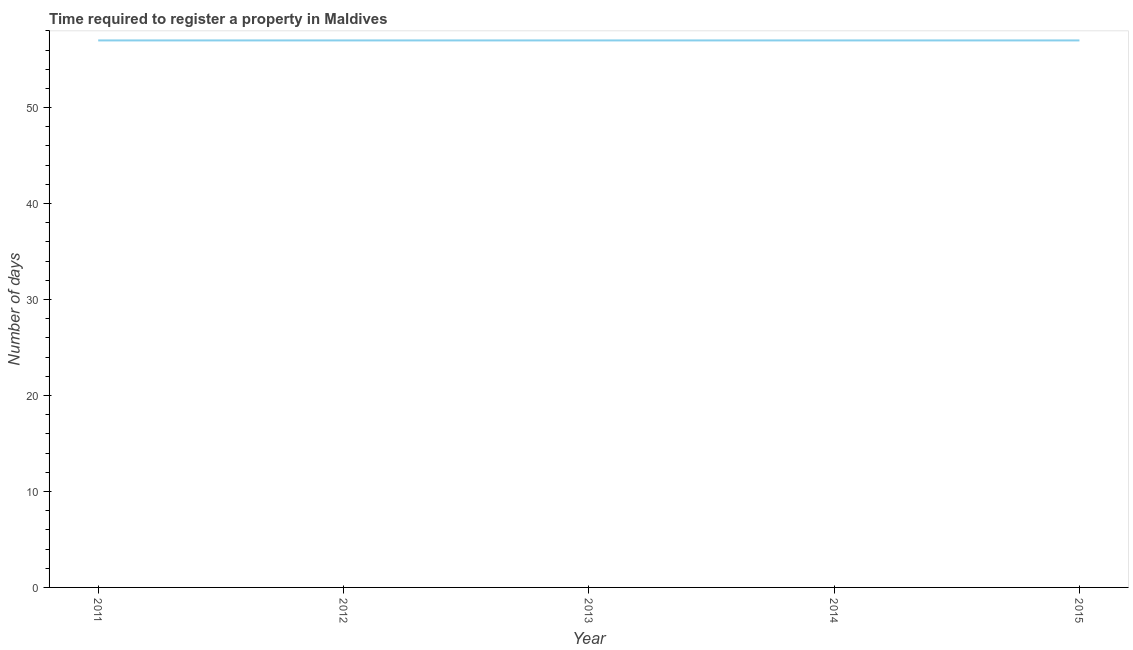What is the number of days required to register property in 2015?
Give a very brief answer. 57. Across all years, what is the maximum number of days required to register property?
Offer a terse response. 57. Across all years, what is the minimum number of days required to register property?
Your response must be concise. 57. What is the sum of the number of days required to register property?
Your response must be concise. 285. What is the difference between the number of days required to register property in 2013 and 2015?
Your response must be concise. 0. What is the median number of days required to register property?
Ensure brevity in your answer.  57. In how many years, is the number of days required to register property greater than 22 days?
Offer a terse response. 5. Do a majority of the years between 2013 and 2014 (inclusive) have number of days required to register property greater than 52 days?
Your response must be concise. Yes. What is the ratio of the number of days required to register property in 2011 to that in 2012?
Keep it short and to the point. 1. What is the difference between the highest and the second highest number of days required to register property?
Ensure brevity in your answer.  0. Is the sum of the number of days required to register property in 2011 and 2013 greater than the maximum number of days required to register property across all years?
Offer a very short reply. Yes. What is the difference between the highest and the lowest number of days required to register property?
Your answer should be compact. 0. In how many years, is the number of days required to register property greater than the average number of days required to register property taken over all years?
Provide a short and direct response. 0. Does the number of days required to register property monotonically increase over the years?
Your answer should be very brief. No. How many years are there in the graph?
Give a very brief answer. 5. Are the values on the major ticks of Y-axis written in scientific E-notation?
Give a very brief answer. No. Does the graph contain any zero values?
Your answer should be very brief. No. What is the title of the graph?
Make the answer very short. Time required to register a property in Maldives. What is the label or title of the Y-axis?
Provide a succinct answer. Number of days. What is the Number of days in 2013?
Keep it short and to the point. 57. What is the Number of days of 2014?
Your answer should be very brief. 57. What is the difference between the Number of days in 2011 and 2013?
Provide a succinct answer. 0. What is the difference between the Number of days in 2012 and 2013?
Offer a very short reply. 0. What is the difference between the Number of days in 2012 and 2014?
Make the answer very short. 0. What is the difference between the Number of days in 2012 and 2015?
Offer a terse response. 0. What is the difference between the Number of days in 2014 and 2015?
Your response must be concise. 0. What is the ratio of the Number of days in 2012 to that in 2013?
Your answer should be compact. 1. What is the ratio of the Number of days in 2013 to that in 2014?
Offer a very short reply. 1. What is the ratio of the Number of days in 2013 to that in 2015?
Provide a succinct answer. 1. 